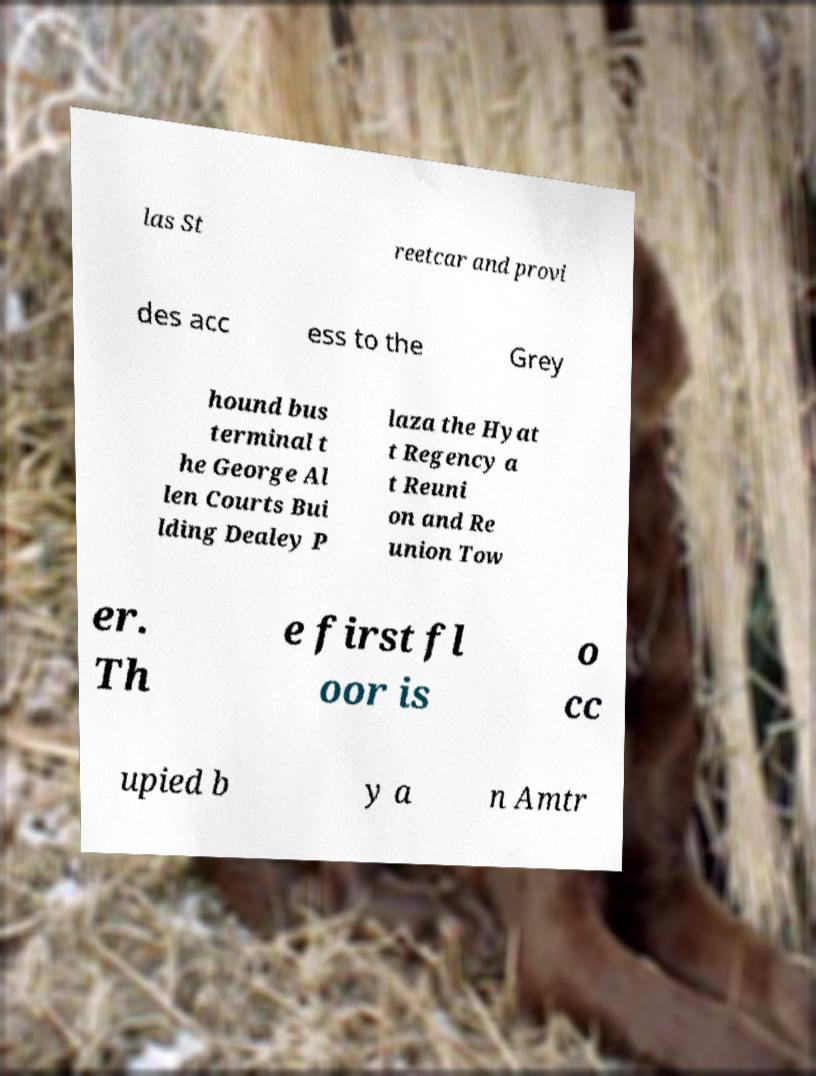Please read and relay the text visible in this image. What does it say? las St reetcar and provi des acc ess to the Grey hound bus terminal t he George Al len Courts Bui lding Dealey P laza the Hyat t Regency a t Reuni on and Re union Tow er. Th e first fl oor is o cc upied b y a n Amtr 